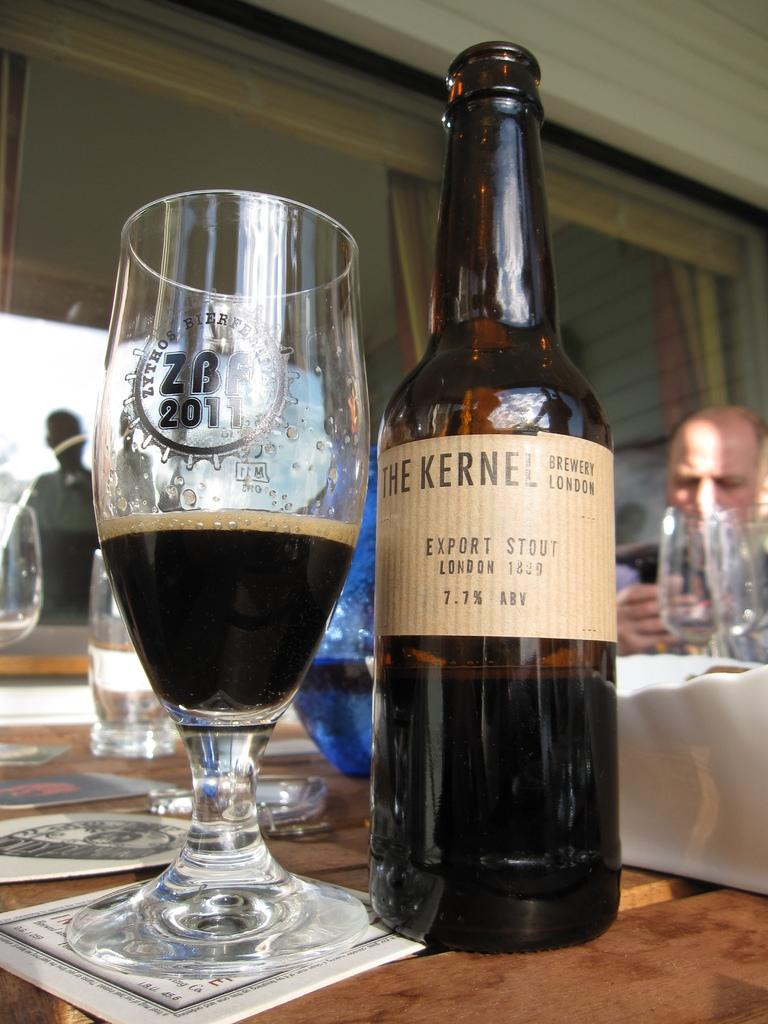What type of glass can be seen in the image? There is a wine glass in the image. What is the wine glass likely to contain? The wine glass is likely to contain wine, as there is a wine bottle in the image. What is the man in the image doing? The man is sitting on a chair in the image. What route does the man take to get to the middle of the image? There is no route or middle of the image to reference, as the image is a still photograph and does not depict movement or a specific location within the frame. 